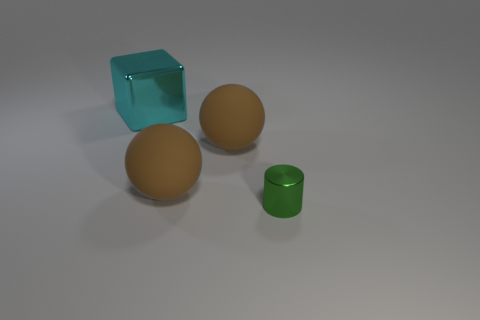Add 2 green metallic objects. How many objects exist? 6 Subtract all cubes. How many objects are left? 3 Subtract 0 yellow spheres. How many objects are left? 4 Subtract all green metallic cylinders. Subtract all small cyan metallic cylinders. How many objects are left? 3 Add 4 cyan shiny blocks. How many cyan shiny blocks are left? 5 Add 4 yellow shiny spheres. How many yellow shiny spheres exist? 4 